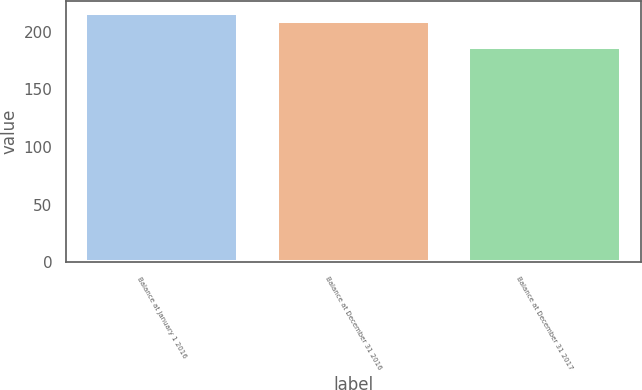<chart> <loc_0><loc_0><loc_500><loc_500><bar_chart><fcel>Balance at January 1 2016<fcel>Balance at December 31 2016<fcel>Balance at December 31 2017<nl><fcel>216<fcel>209<fcel>187<nl></chart> 